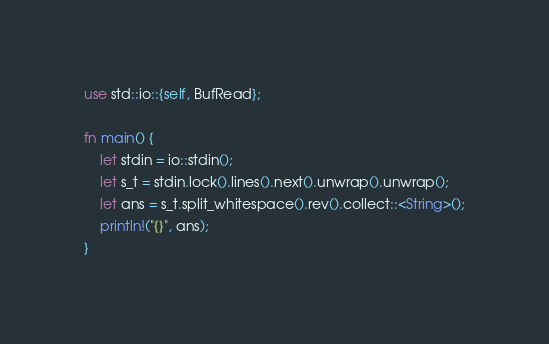<code> <loc_0><loc_0><loc_500><loc_500><_Rust_>use std::io::{self, BufRead};

fn main() {
    let stdin = io::stdin();
    let s_t = stdin.lock().lines().next().unwrap().unwrap();
    let ans = s_t.split_whitespace().rev().collect::<String>();
    println!("{}", ans);
}
</code> 